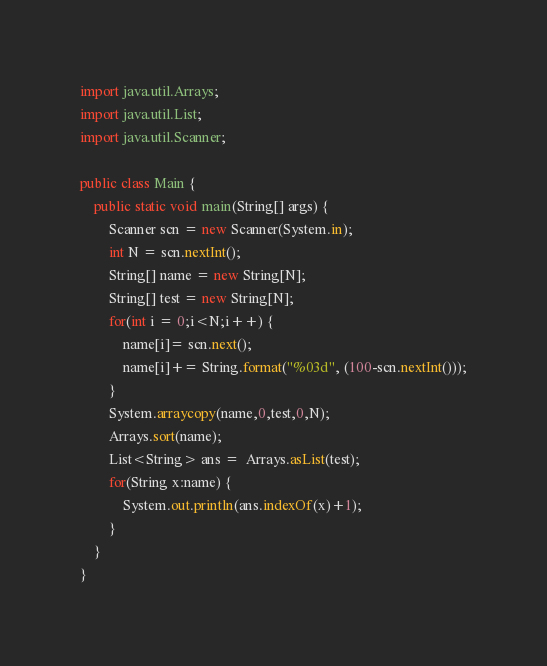Convert code to text. <code><loc_0><loc_0><loc_500><loc_500><_Java_>import java.util.Arrays;
import java.util.List;
import java.util.Scanner;

public class Main {
	public static void main(String[] args) {
		Scanner scn = new Scanner(System.in);
		int N = scn.nextInt();
		String[] name = new String[N];
		String[] test = new String[N];
		for(int i = 0;i<N;i++) {
			name[i]= scn.next();
			name[i]+= String.format("%03d", (100-scn.nextInt()));
		}
		System.arraycopy(name,0,test,0,N);
		Arrays.sort(name);
		List<String> ans =  Arrays.asList(test);
		for(String x:name) {
			System.out.println(ans.indexOf(x)+1);
		}
	}
}</code> 